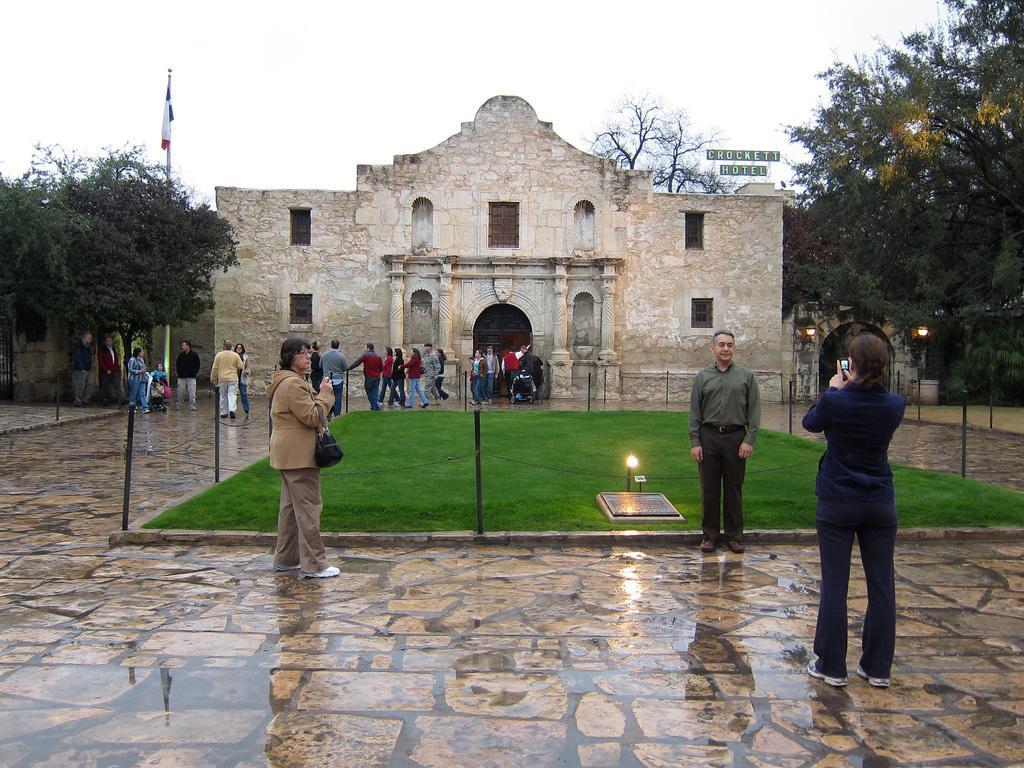How would you summarize this image in a sentence or two? In this picture there are people on the surface and we can see poles, chains, lights, boards, flag, trees and building. In the background of the image we can see the sky. 